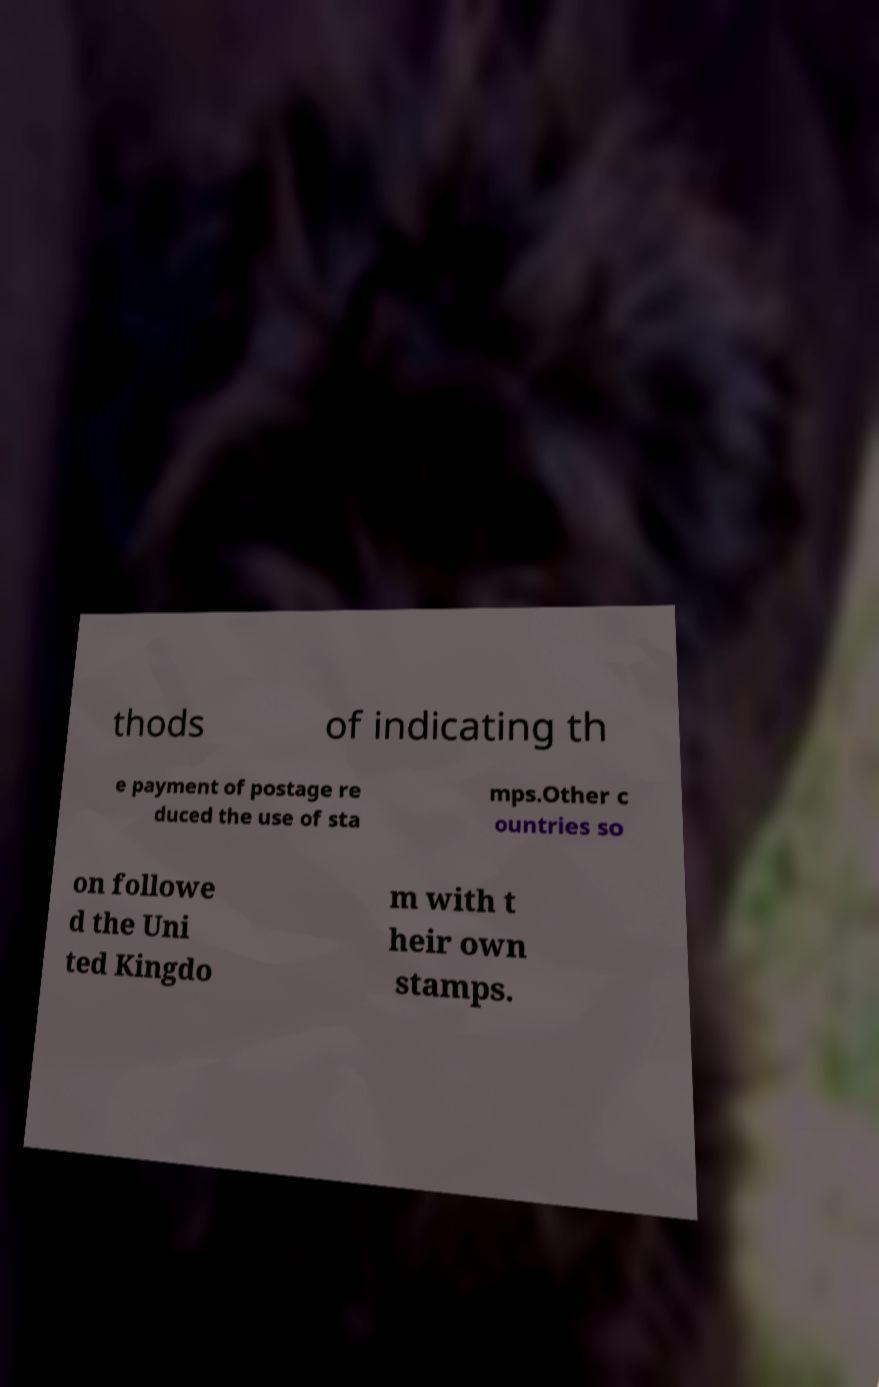Can you accurately transcribe the text from the provided image for me? thods of indicating th e payment of postage re duced the use of sta mps.Other c ountries so on followe d the Uni ted Kingdo m with t heir own stamps. 